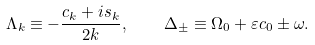<formula> <loc_0><loc_0><loc_500><loc_500>\Lambda _ { k } \equiv - \frac { c _ { k } + i s _ { k } } { 2 k } , \quad \Delta _ { \pm } \equiv \Omega _ { 0 } + \varepsilon c _ { 0 } \pm \omega .</formula> 